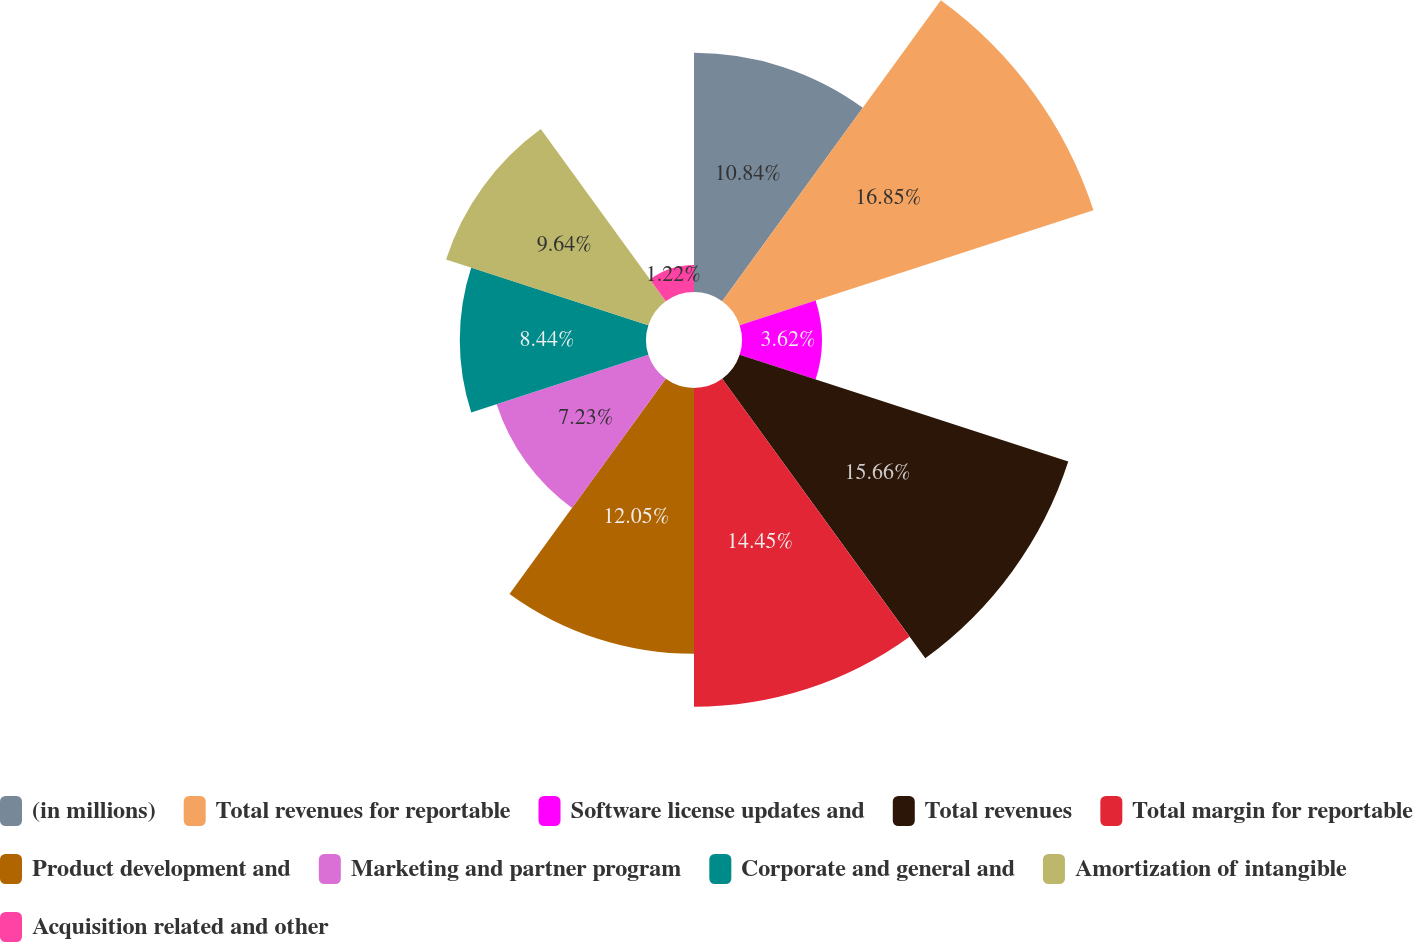Convert chart to OTSL. <chart><loc_0><loc_0><loc_500><loc_500><pie_chart><fcel>(in millions)<fcel>Total revenues for reportable<fcel>Software license updates and<fcel>Total revenues<fcel>Total margin for reportable<fcel>Product development and<fcel>Marketing and partner program<fcel>Corporate and general and<fcel>Amortization of intangible<fcel>Acquisition related and other<nl><fcel>10.84%<fcel>16.86%<fcel>3.62%<fcel>15.66%<fcel>14.45%<fcel>12.05%<fcel>7.23%<fcel>8.44%<fcel>9.64%<fcel>1.22%<nl></chart> 